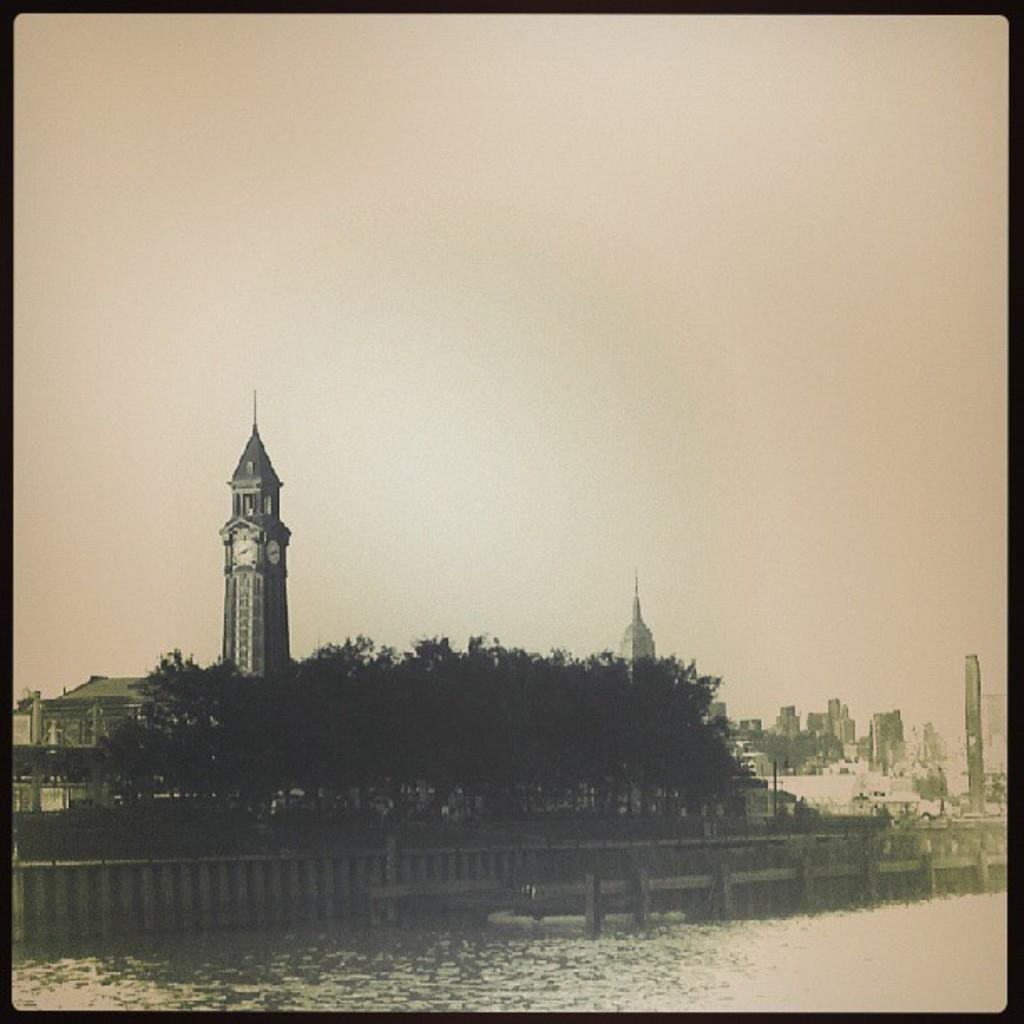What is the primary element visible in the image? There is water in the image. What type of structure can be seen in the image? There is a fence in the image. What type of vegetation is present in the image? There are trees in the image. What type of man-made structures are visible in the image? There are buildings in the image. What part of the natural environment is visible in the image? The sky is visible in the image. How does the fireman put out the fire on the roof in the image? There is no fire or fireman present in the image; it features water, a fence, trees, buildings, and the sky. 